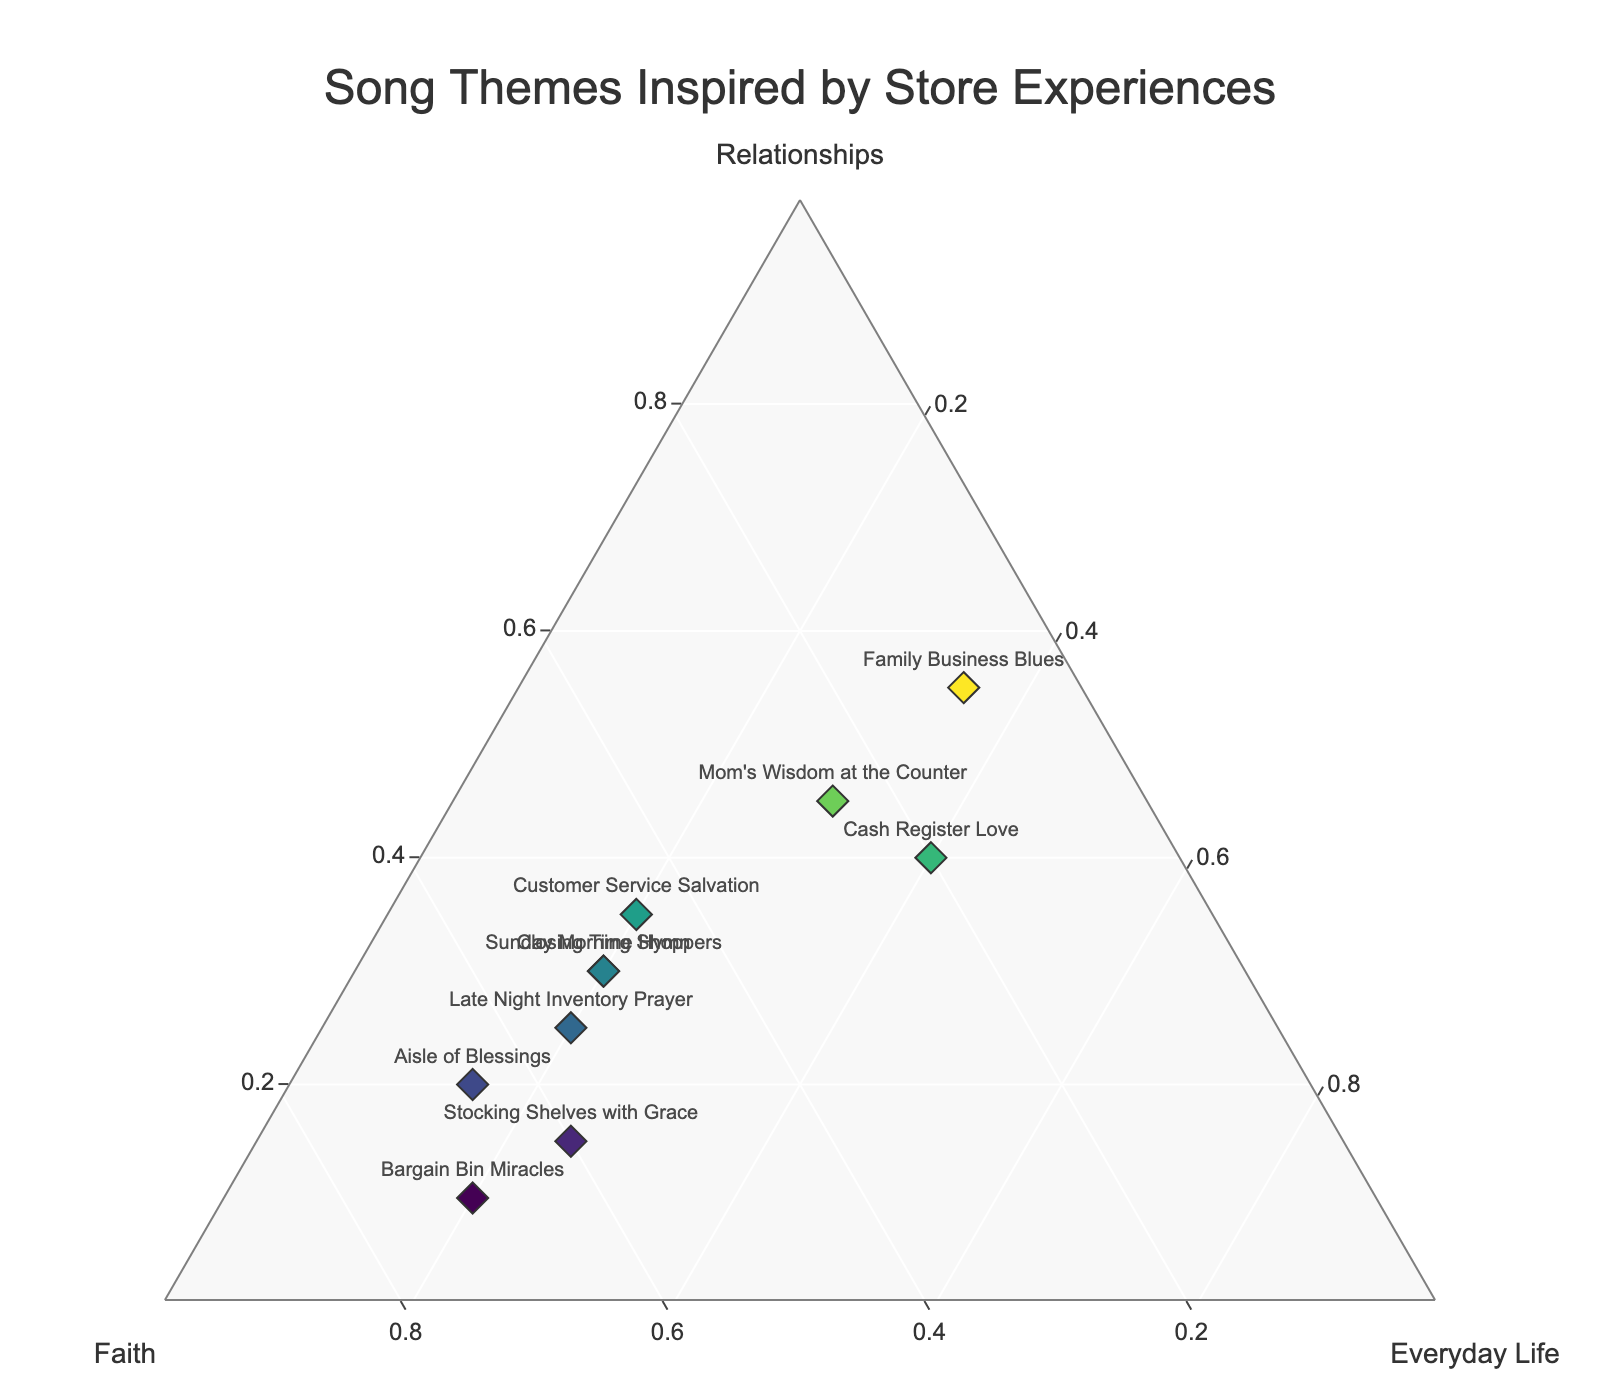what is the title of the plot? The title appears at the top center of the plot. It is specified to represent the overall theme or subject of the data shown. The exact text used is "Song Themes Inspired by Store Experiences".
Answer: "Song Themes Inspired by Store Experiences" how many songs have relationships as their primary theme? To determine this, look at the data points where the proportion of relationships is higher than the proportions of faith and everyday life. The song titles "Cash Register Love" and "Family Business Blues" have relationships as their primary theme.
Answer: 2 which song has the highest proportion of faith in its theme? Look for the data point with the highest value on the faith axis. The song "Bargain Bin Miracles" has the highest value with 70%.
Answer: "Bargain Bin Miracles" which song has an equal proportion of relationships and everyday life in its theme? Identify the data point where the values for relationships and everyday life are identical. The song "Cash Register Love" has both relationships and everyday life at 40%.
Answer: "Cash Register Love" what is the combined proportion of faith and everyday life for "Sunday Morning Shoppers"? Add the proportion values for faith and everyday life from the data point of "Sunday Morning Shoppers". Faith is 50% and everyday life is 20%. So, the combined proportion is 50 + 20.
Answer: 70% how many songs have a higher proportion of faith than 50%? Check all the data points and count those where the faith percentage is greater than 50%. The songs are "Stocking Shelves with Grace", "Aisle of Blessings", "Late Night Inventory Prayer", and "Bargain Bin Miracles".
Answer: 4 which section of the ternary plot is populated by more songs: faith-focused, relationship-focused, or everyday life-focused themes? Compare the number of data points that fall primarily in each section. Faith-focused themes have "Stocking Shelves with Grace", "Aisle of Blessings", "Late Night Inventory Prayer", and "Bargain Bin Miracles" making it the section with the most songs.
Answer: faith-focused themes which song titles have a higher proportion of relationships than faith? Look for song titles where the percentage of relationships is greater than that of faith. "Cash Register Love", "Family Business Blues", "Customer Service Salvation", and "Mom's Wisdom at the Counter" meet this requirement.
Answer: 4 what is the proportion of everyday life in the theme for "Mom's Wisdom at the Counter"? Look at the given value in the data for everyday life in "Mom's Wisdom at the Counter". The specific value provided is 30%.
Answer: 30% which song themes have the most balanced proportions among the three categories? Identify songs where the proportions of relationships, faith, and everyday life are closest to each other. "Cash Register Love" with 40% relationships, 20% faith, and 40% everyday life is the most balanced among the given data points.
Answer: "Cash Register Love" 